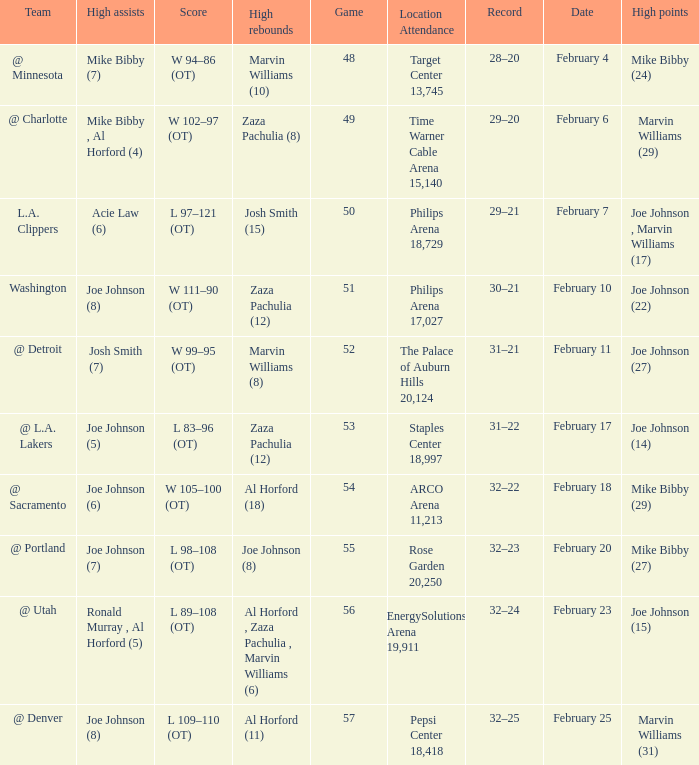How many high assists stats were maade on february 4 1.0. 